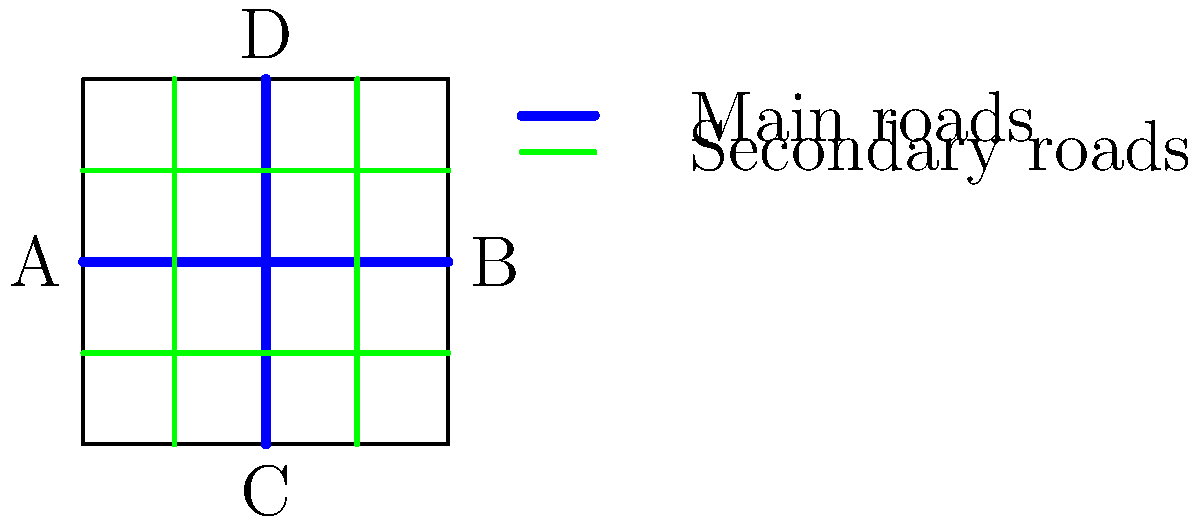As a political reporter in Lesotho, you're covering a story on urban development in Maseru. The city planners have proposed a new grid-based road network layout, as shown in the simplified map above. If a vehicle travels from point A to point B using only main roads, and then returns to point A using only secondary roads, what is the ratio of the distance traveled on the return trip compared to the initial trip? Let's approach this step-by-step:

1. Initial trip (A to B):
   - The vehicle travels on the main road (blue) from A to B.
   - This is a straight line across the entire width of the city.
   - Let's call the width of the city $x$.
   - Distance of initial trip = $x$

2. Return trip (B to A):
   - The vehicle must use only secondary roads (green).
   - The shortest path would be to go halfway up, across, and halfway down.
   - This forms a "stairstep" pattern.
   - The vertical distance is the height of the city, let's call it $y$.
   - The horizontal distance is still $x$.
   - Total distance of return trip = $y + x$

3. Ratio calculation:
   - Ratio = (Return trip distance) : (Initial trip distance)
   - Ratio = $(y + x) : x$
   - Simplified ratio = $(y/x + 1) : 1$

4. Observing the map:
   - The city appears to be a square.
   - In a square, height equals width, so $y = x$.

5. Final ratio:
   - Substituting $y = x$ in our ratio:
   - Ratio = $(x/x + 1) : 1 = 2 : 1$

Therefore, the return trip using secondary roads is twice the distance of the initial trip using main roads.
Answer: 2:1 